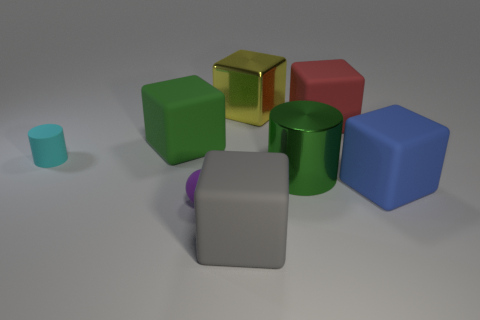Subtract all red cubes. How many cubes are left? 4 Subtract all cyan cubes. Subtract all green spheres. How many cubes are left? 5 Add 1 small purple matte balls. How many objects exist? 9 Subtract all cylinders. How many objects are left? 6 Subtract 0 brown blocks. How many objects are left? 8 Subtract all gray rubber cubes. Subtract all big blue cubes. How many objects are left? 6 Add 5 big green objects. How many big green objects are left? 7 Add 3 big brown metallic things. How many big brown metallic things exist? 3 